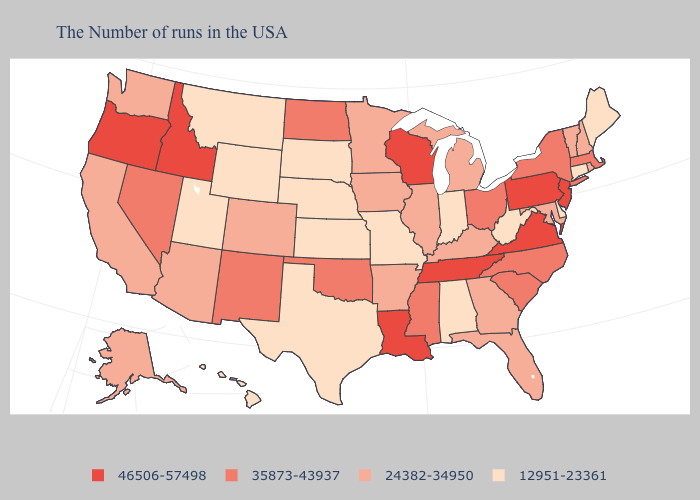Does the first symbol in the legend represent the smallest category?
Write a very short answer. No. Which states hav the highest value in the Northeast?
Quick response, please. New Jersey, Pennsylvania. Among the states that border Montana , which have the lowest value?
Answer briefly. South Dakota, Wyoming. Among the states that border Arkansas , which have the lowest value?
Concise answer only. Missouri, Texas. Which states have the lowest value in the South?
Keep it brief. Delaware, West Virginia, Alabama, Texas. Does North Carolina have the lowest value in the South?
Concise answer only. No. What is the lowest value in the West?
Short answer required. 12951-23361. Does the first symbol in the legend represent the smallest category?
Short answer required. No. Does Nebraska have the highest value in the USA?
Be succinct. No. Which states have the highest value in the USA?
Keep it brief. New Jersey, Pennsylvania, Virginia, Tennessee, Wisconsin, Louisiana, Idaho, Oregon. Name the states that have a value in the range 35873-43937?
Concise answer only. Massachusetts, New York, North Carolina, South Carolina, Ohio, Mississippi, Oklahoma, North Dakota, New Mexico, Nevada. Name the states that have a value in the range 24382-34950?
Answer briefly. Rhode Island, New Hampshire, Vermont, Maryland, Florida, Georgia, Michigan, Kentucky, Illinois, Arkansas, Minnesota, Iowa, Colorado, Arizona, California, Washington, Alaska. Name the states that have a value in the range 12951-23361?
Give a very brief answer. Maine, Connecticut, Delaware, West Virginia, Indiana, Alabama, Missouri, Kansas, Nebraska, Texas, South Dakota, Wyoming, Utah, Montana, Hawaii. Does Illinois have a higher value than Florida?
Write a very short answer. No. What is the value of Oklahoma?
Answer briefly. 35873-43937. 